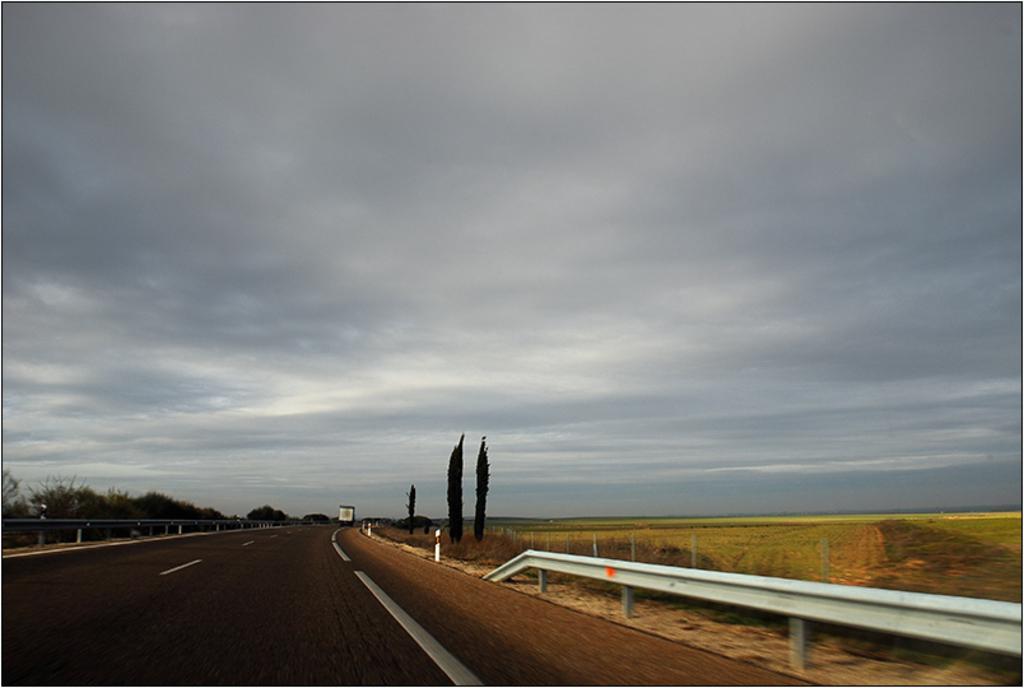Describe this image in one or two sentences. In this image there is a vehicle passing on the road, on the either side of the road there is a metal fence, on the other side of the fence there are trees. 